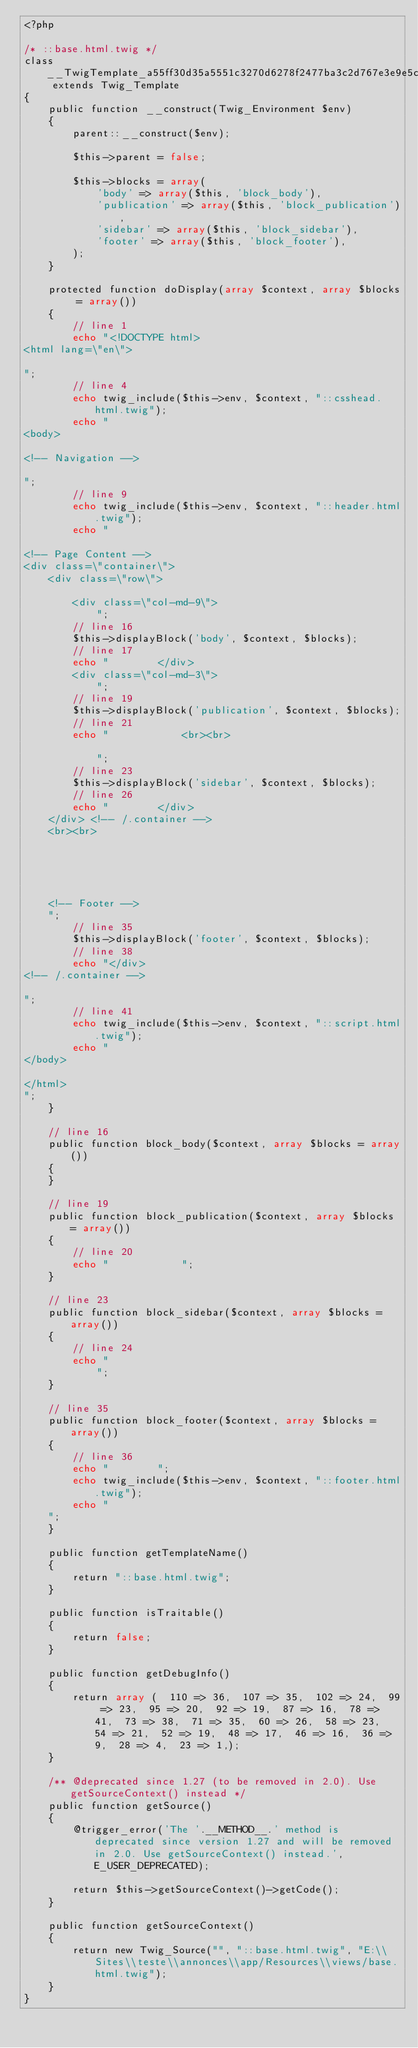<code> <loc_0><loc_0><loc_500><loc_500><_PHP_><?php

/* ::base.html.twig */
class __TwigTemplate_a55ff30d35a5551c3270d6278f2477ba3c2d767e3e9e5c40ae34e7aee290be6e extends Twig_Template
{
    public function __construct(Twig_Environment $env)
    {
        parent::__construct($env);

        $this->parent = false;

        $this->blocks = array(
            'body' => array($this, 'block_body'),
            'publication' => array($this, 'block_publication'),
            'sidebar' => array($this, 'block_sidebar'),
            'footer' => array($this, 'block_footer'),
        );
    }

    protected function doDisplay(array $context, array $blocks = array())
    {
        // line 1
        echo "<!DOCTYPE html>
<html lang=\"en\">

";
        // line 4
        echo twig_include($this->env, $context, "::csshead.html.twig");
        echo "
<body>

<!-- Navigation -->

";
        // line 9
        echo twig_include($this->env, $context, "::header.html.twig");
        echo "

<!-- Page Content -->
<div class=\"container\">
    <div class=\"row\">

        <div class=\"col-md-9\">
            ";
        // line 16
        $this->displayBlock('body', $context, $blocks);
        // line 17
        echo "        </div>
        <div class=\"col-md-3\">
            ";
        // line 19
        $this->displayBlock('publication', $context, $blocks);
        // line 21
        echo "            <br><br>

            ";
        // line 23
        $this->displayBlock('sidebar', $context, $blocks);
        // line 26
        echo "        </div>
    </div> <!-- /.container -->
    <br><br>





    <!-- Footer -->
    ";
        // line 35
        $this->displayBlock('footer', $context, $blocks);
        // line 38
        echo "</div>
<!-- /.container -->

";
        // line 41
        echo twig_include($this->env, $context, "::script.html.twig");
        echo "
</body>

</html>
";
    }

    // line 16
    public function block_body($context, array $blocks = array())
    {
    }

    // line 19
    public function block_publication($context, array $blocks = array())
    {
        // line 20
        echo "            ";
    }

    // line 23
    public function block_sidebar($context, array $blocks = array())
    {
        // line 24
        echo "
            ";
    }

    // line 35
    public function block_footer($context, array $blocks = array())
    {
        // line 36
        echo "        ";
        echo twig_include($this->env, $context, "::footer.html.twig");
        echo "
    ";
    }

    public function getTemplateName()
    {
        return "::base.html.twig";
    }

    public function isTraitable()
    {
        return false;
    }

    public function getDebugInfo()
    {
        return array (  110 => 36,  107 => 35,  102 => 24,  99 => 23,  95 => 20,  92 => 19,  87 => 16,  78 => 41,  73 => 38,  71 => 35,  60 => 26,  58 => 23,  54 => 21,  52 => 19,  48 => 17,  46 => 16,  36 => 9,  28 => 4,  23 => 1,);
    }

    /** @deprecated since 1.27 (to be removed in 2.0). Use getSourceContext() instead */
    public function getSource()
    {
        @trigger_error('The '.__METHOD__.' method is deprecated since version 1.27 and will be removed in 2.0. Use getSourceContext() instead.', E_USER_DEPRECATED);

        return $this->getSourceContext()->getCode();
    }

    public function getSourceContext()
    {
        return new Twig_Source("", "::base.html.twig", "E:\\Sites\\teste\\annonces\\app/Resources\\views/base.html.twig");
    }
}
</code> 